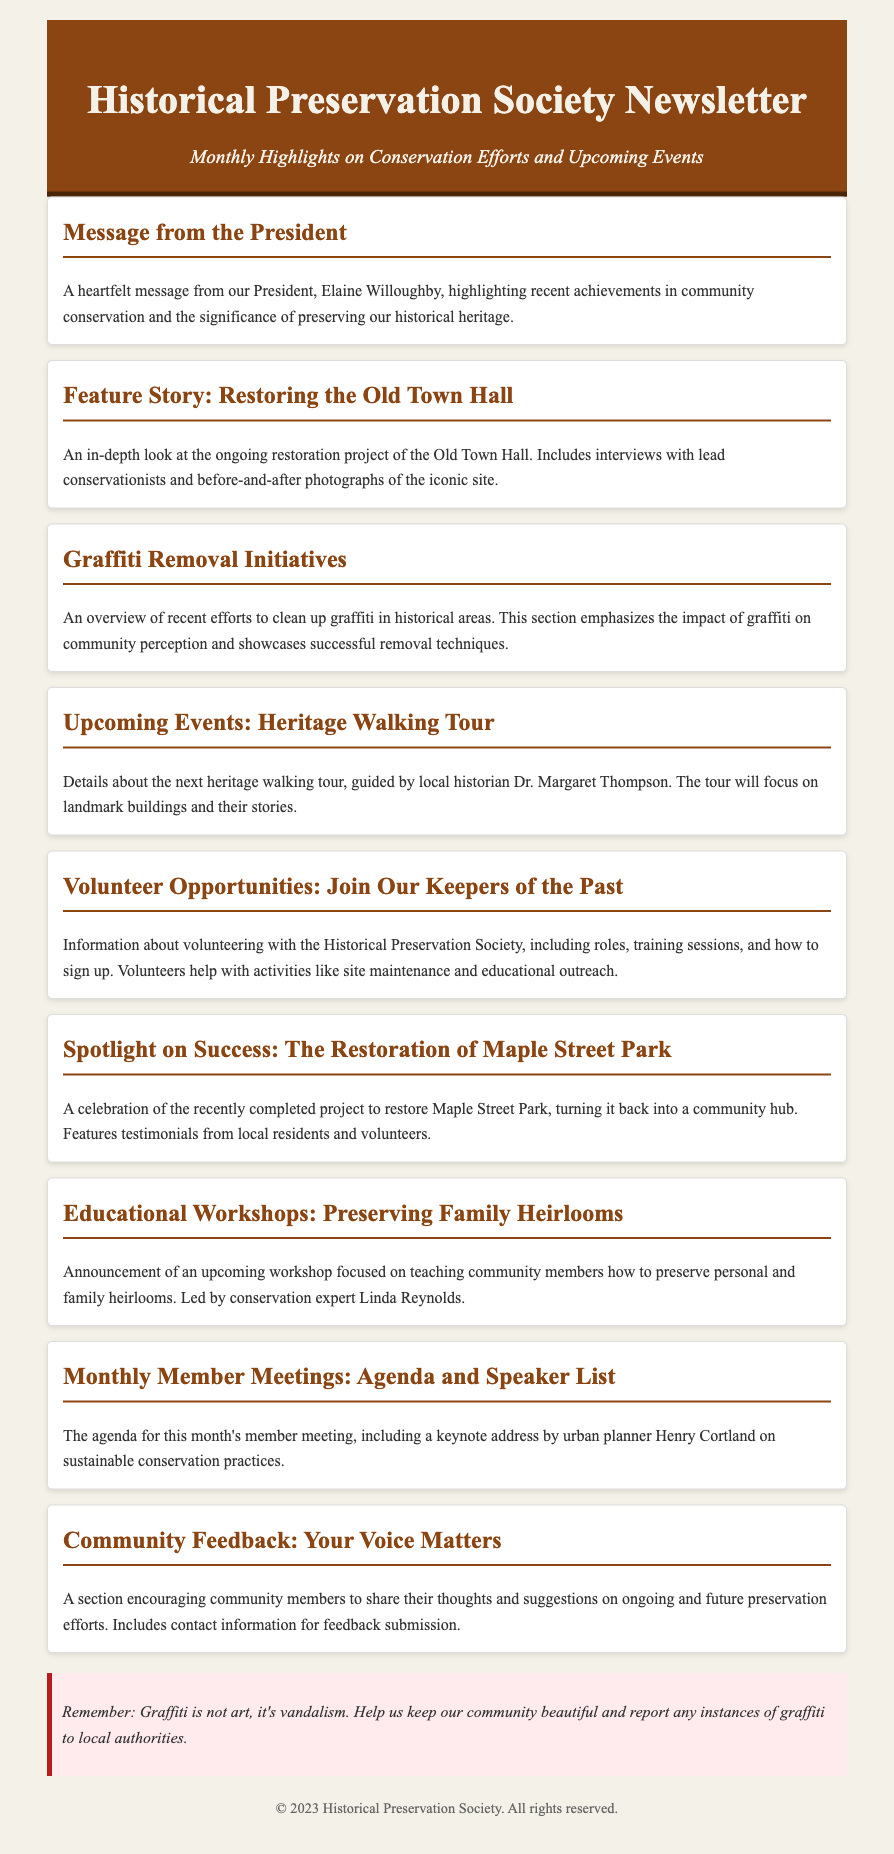What is the name of the President? The document mentions Elaine Willoughby as the President in the message from the President section.
Answer: Elaine Willoughby What is the feature story about? The feature story discusses the ongoing restoration project of a significant historical site as indicated in its title.
Answer: Restoring the Old Town Hall What is the focus of the graffiti removal initiatives? The graffiti removal initiatives emphasize the impact of graffiti on community perception and the techniques used for its removal.
Answer: Impact of graffiti Who is guiding the upcoming heritage walking tour? The upcoming heritage walking tour will be guided by a local historian whose name is provided in the document.
Answer: Dr. Margaret Thompson What type of opportunities does the Historical Preservation Society offer? The document provides details about volunteering with the society, mentioning specific roles and activities.
Answer: Volunteer Opportunities What workshop is being announced in the newsletter? The newsletter announces a workshop focused on preserving personal and family heirlooms, detailing what participants can expect.
Answer: Preserving Family Heirlooms What is a key theme in the community feedback section? The community feedback section encourages members to share their thoughts, which highlights the importance of community participation.
Answer: Your Voice Matters How many months of member meetings are referenced? The document indicates the agenda for this month's member meeting, suggesting it's a monthly occurrence.
Answer: This month What warning is given regarding graffiti? The document includes a specific note on the nature of graffiti, suggesting a clear stance against it.
Answer: Graffiti is not art, it's vandalism 